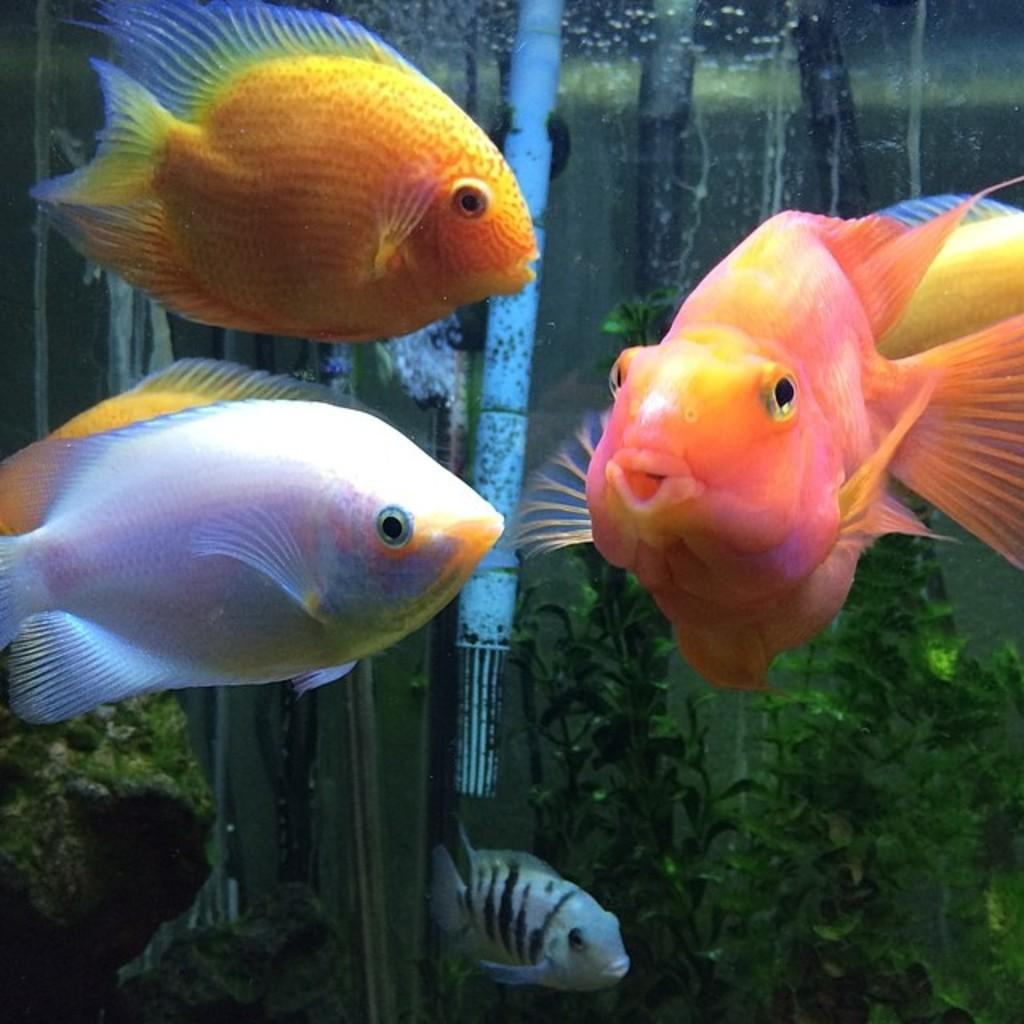How many fish are visible in the image? There are four fish in the image. Can you describe the fish in terms of their sizes? The fish are of different sizes. What colors can be seen on the fish? The fish have different colors. What else is present in the water besides the fish? There are water plants in the image. What other object can be seen in the image? There is a pole-like object in the image. How many eggs are being carried by the fish in the image? There are no eggs visible in the image; the focus is on the fish and their sizes, colors, and the presence of water plants and a pole-like object. 